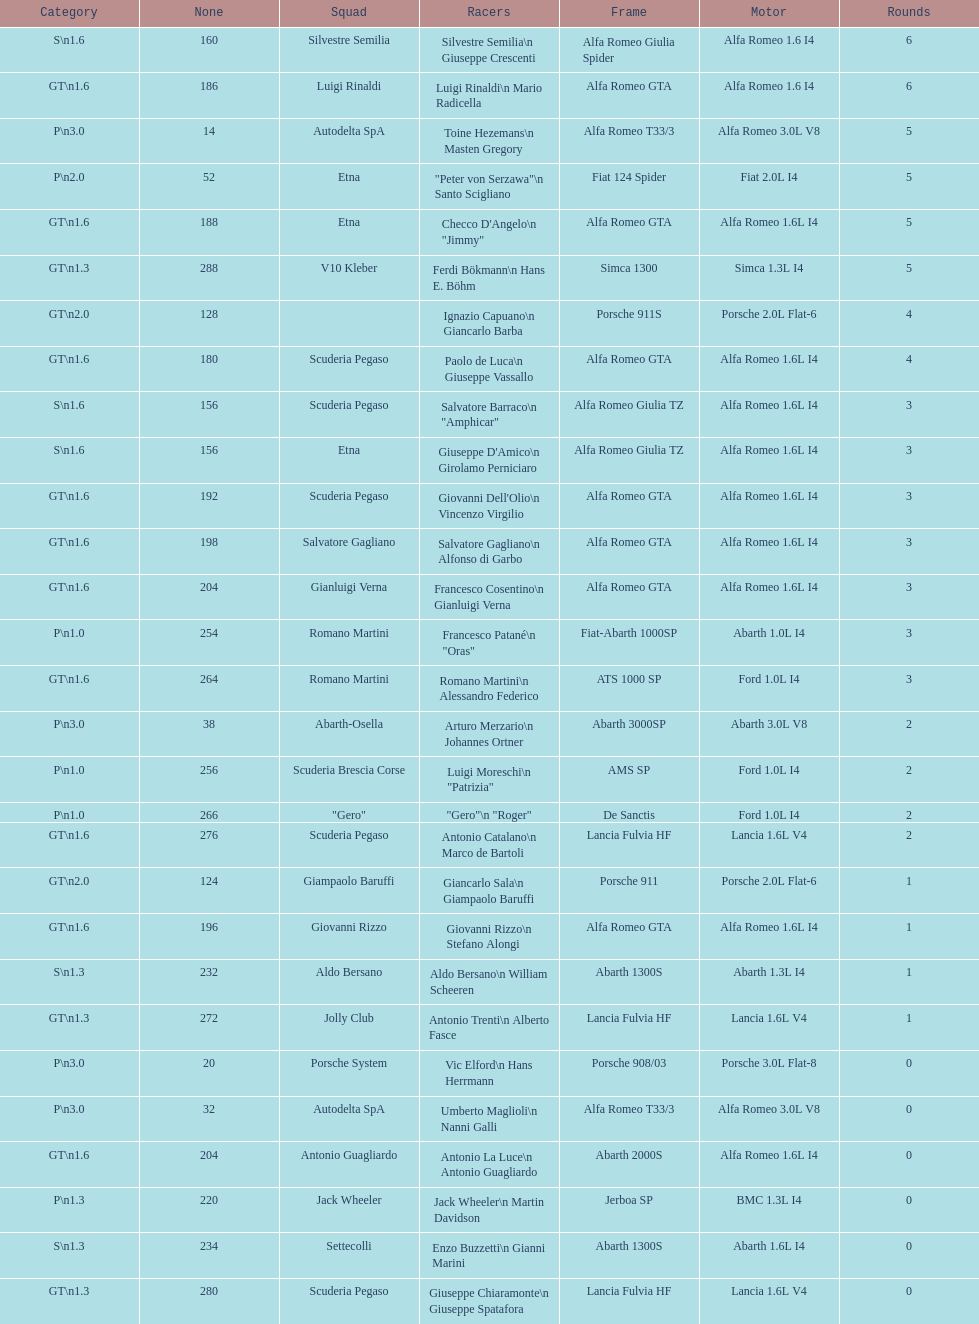Name the only american who did not finish the race. Masten Gregory. Can you give me this table as a dict? {'header': ['Category', 'None', 'Squad', 'Racers', 'Frame', 'Motor', 'Rounds'], 'rows': [['S\\n1.6', '160', 'Silvestre Semilia', 'Silvestre Semilia\\n Giuseppe Crescenti', 'Alfa Romeo Giulia Spider', 'Alfa Romeo 1.6 I4', '6'], ['GT\\n1.6', '186', 'Luigi Rinaldi', 'Luigi Rinaldi\\n Mario Radicella', 'Alfa Romeo GTA', 'Alfa Romeo 1.6 I4', '6'], ['P\\n3.0', '14', 'Autodelta SpA', 'Toine Hezemans\\n Masten Gregory', 'Alfa Romeo T33/3', 'Alfa Romeo 3.0L V8', '5'], ['P\\n2.0', '52', 'Etna', '"Peter von Serzawa"\\n Santo Scigliano', 'Fiat 124 Spider', 'Fiat 2.0L I4', '5'], ['GT\\n1.6', '188', 'Etna', 'Checco D\'Angelo\\n "Jimmy"', 'Alfa Romeo GTA', 'Alfa Romeo 1.6L I4', '5'], ['GT\\n1.3', '288', 'V10 Kleber', 'Ferdi Bökmann\\n Hans E. Böhm', 'Simca 1300', 'Simca 1.3L I4', '5'], ['GT\\n2.0', '128', '', 'Ignazio Capuano\\n Giancarlo Barba', 'Porsche 911S', 'Porsche 2.0L Flat-6', '4'], ['GT\\n1.6', '180', 'Scuderia Pegaso', 'Paolo de Luca\\n Giuseppe Vassallo', 'Alfa Romeo GTA', 'Alfa Romeo 1.6L I4', '4'], ['S\\n1.6', '156', 'Scuderia Pegaso', 'Salvatore Barraco\\n "Amphicar"', 'Alfa Romeo Giulia TZ', 'Alfa Romeo 1.6L I4', '3'], ['S\\n1.6', '156', 'Etna', "Giuseppe D'Amico\\n Girolamo Perniciaro", 'Alfa Romeo Giulia TZ', 'Alfa Romeo 1.6L I4', '3'], ['GT\\n1.6', '192', 'Scuderia Pegaso', "Giovanni Dell'Olio\\n Vincenzo Virgilio", 'Alfa Romeo GTA', 'Alfa Romeo 1.6L I4', '3'], ['GT\\n1.6', '198', 'Salvatore Gagliano', 'Salvatore Gagliano\\n Alfonso di Garbo', 'Alfa Romeo GTA', 'Alfa Romeo 1.6L I4', '3'], ['GT\\n1.6', '204', 'Gianluigi Verna', 'Francesco Cosentino\\n Gianluigi Verna', 'Alfa Romeo GTA', 'Alfa Romeo 1.6L I4', '3'], ['P\\n1.0', '254', 'Romano Martini', 'Francesco Patané\\n "Oras"', 'Fiat-Abarth 1000SP', 'Abarth 1.0L I4', '3'], ['GT\\n1.6', '264', 'Romano Martini', 'Romano Martini\\n Alessandro Federico', 'ATS 1000 SP', 'Ford 1.0L I4', '3'], ['P\\n3.0', '38', 'Abarth-Osella', 'Arturo Merzario\\n Johannes Ortner', 'Abarth 3000SP', 'Abarth 3.0L V8', '2'], ['P\\n1.0', '256', 'Scuderia Brescia Corse', 'Luigi Moreschi\\n "Patrizia"', 'AMS SP', 'Ford 1.0L I4', '2'], ['P\\n1.0', '266', '"Gero"', '"Gero"\\n "Roger"', 'De Sanctis', 'Ford 1.0L I4', '2'], ['GT\\n1.6', '276', 'Scuderia Pegaso', 'Antonio Catalano\\n Marco de Bartoli', 'Lancia Fulvia HF', 'Lancia 1.6L V4', '2'], ['GT\\n2.0', '124', 'Giampaolo Baruffi', 'Giancarlo Sala\\n Giampaolo Baruffi', 'Porsche 911', 'Porsche 2.0L Flat-6', '1'], ['GT\\n1.6', '196', 'Giovanni Rizzo', 'Giovanni Rizzo\\n Stefano Alongi', 'Alfa Romeo GTA', 'Alfa Romeo 1.6L I4', '1'], ['S\\n1.3', '232', 'Aldo Bersano', 'Aldo Bersano\\n William Scheeren', 'Abarth 1300S', 'Abarth 1.3L I4', '1'], ['GT\\n1.3', '272', 'Jolly Club', 'Antonio Trenti\\n Alberto Fasce', 'Lancia Fulvia HF', 'Lancia 1.6L V4', '1'], ['P\\n3.0', '20', 'Porsche System', 'Vic Elford\\n Hans Herrmann', 'Porsche 908/03', 'Porsche 3.0L Flat-8', '0'], ['P\\n3.0', '32', 'Autodelta SpA', 'Umberto Maglioli\\n Nanni Galli', 'Alfa Romeo T33/3', 'Alfa Romeo 3.0L V8', '0'], ['GT\\n1.6', '204', 'Antonio Guagliardo', 'Antonio La Luce\\n Antonio Guagliardo', 'Abarth 2000S', 'Alfa Romeo 1.6L I4', '0'], ['P\\n1.3', '220', 'Jack Wheeler', 'Jack Wheeler\\n Martin Davidson', 'Jerboa SP', 'BMC 1.3L I4', '0'], ['S\\n1.3', '234', 'Settecolli', 'Enzo Buzzetti\\n Gianni Marini', 'Abarth 1300S', 'Abarth 1.6L I4', '0'], ['GT\\n1.3', '280', 'Scuderia Pegaso', 'Giuseppe Chiaramonte\\n Giuseppe Spatafora', 'Lancia Fulvia HF', 'Lancia 1.6L V4', '0']]} 